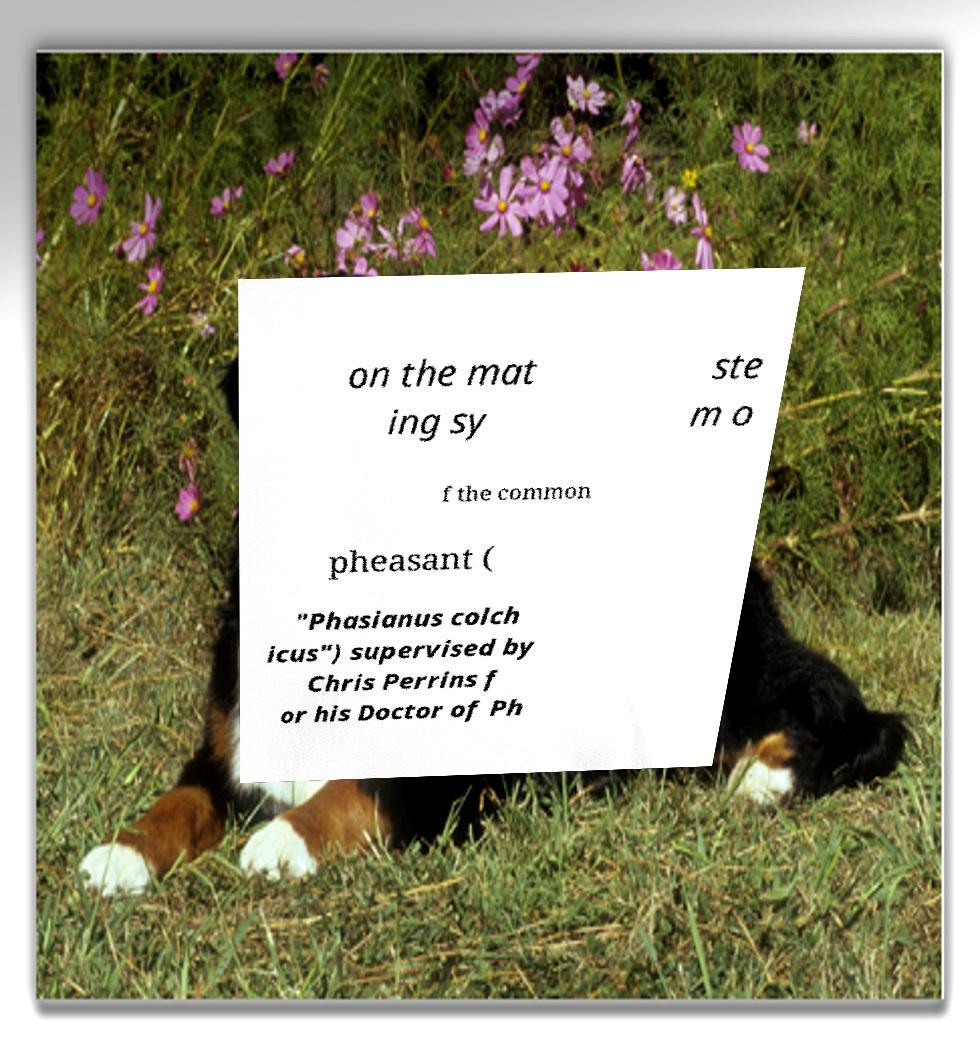I need the written content from this picture converted into text. Can you do that? on the mat ing sy ste m o f the common pheasant ( "Phasianus colch icus") supervised by Chris Perrins f or his Doctor of Ph 